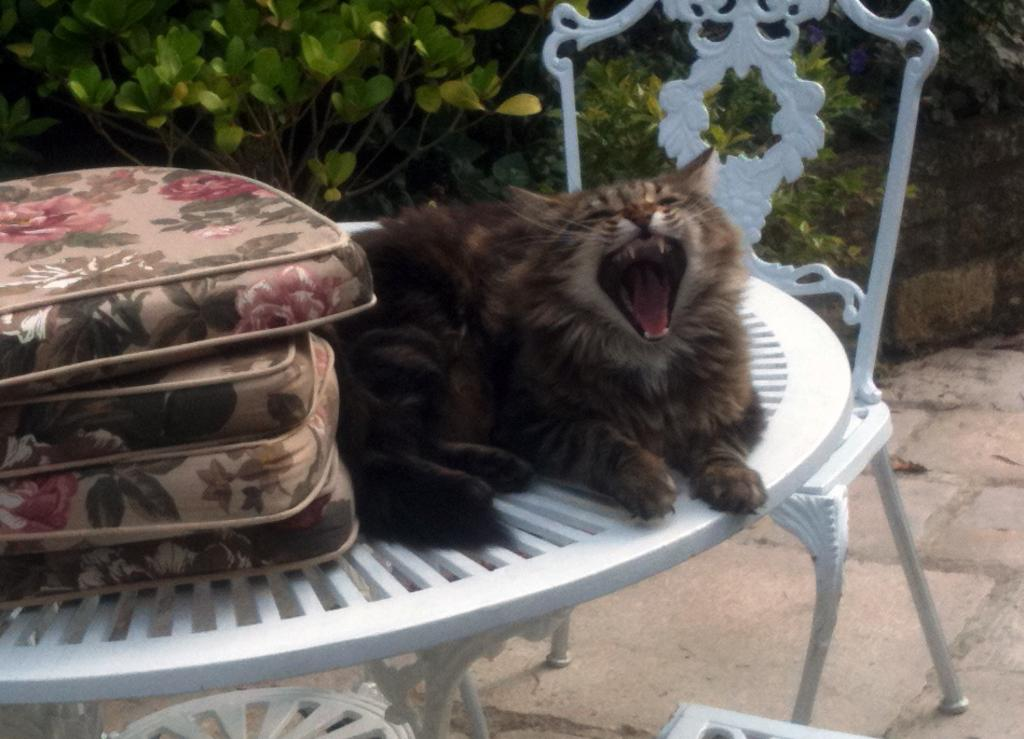What animal is sitting in the image? There is a cat sitting in the image. What can be seen on the table in the image? There are objects on a table in the image. What type of furniture is near the table in the image? There are chairs on the floor near the table in the image. What type of vegetation is visible in the background of the image? There are plants in the background of the image. What disease is the cat suffering from in the image? There is no indication of any disease in the image; the cat appears to be sitting normally. 